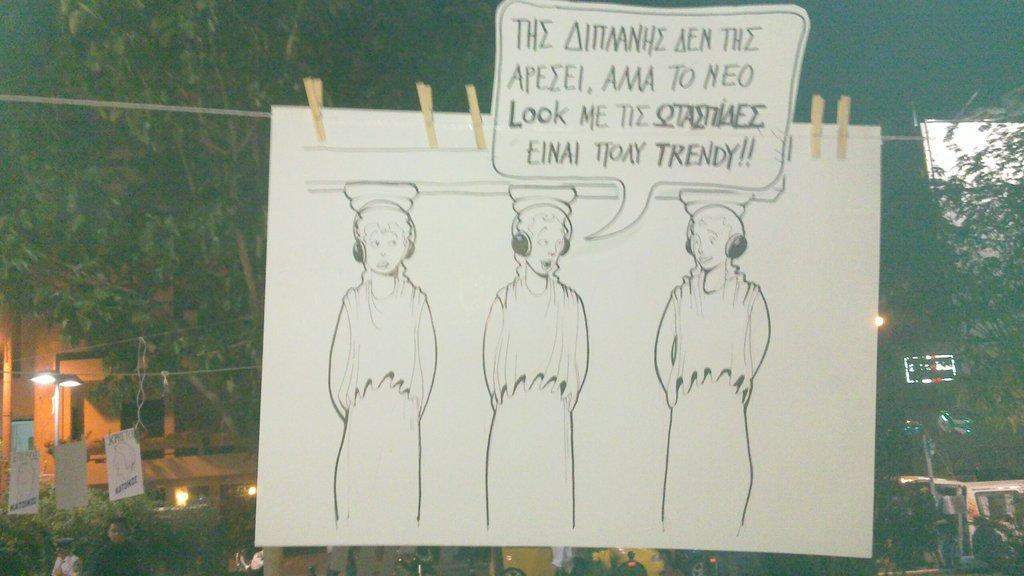What is depicted on the poster in the image? There is a drawing of persons on a poster in the image. What else can be seen on the poster besides the drawing? Text is written on the poster. What other objects or features are present in the image? There are banners, lights, vehicles, trees, a building, and people in the image. What type of soap is being used by the people in the image? There is no soap present in the image; it features a poster with a drawing of persons, banners, lights, vehicles, trees, a building, and people. What statement is being made by the bed in the image? There is no bed present in the image, so no statement can be made by it. 